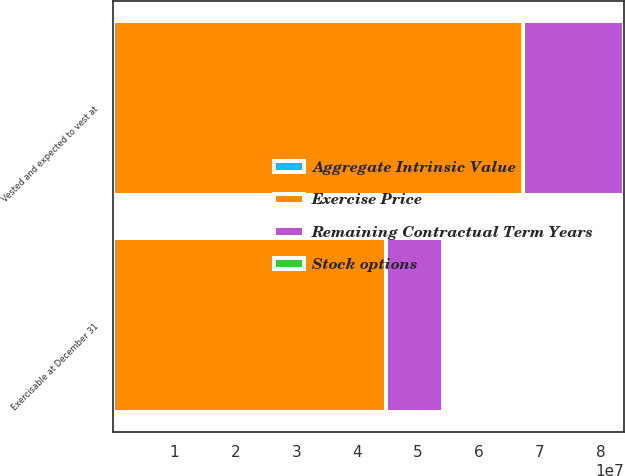<chart> <loc_0><loc_0><loc_500><loc_500><stacked_bar_chart><ecel><fcel>Vested and expected to vest at<fcel>Exercisable at December 31<nl><fcel>Remaining Contractual Term Years<fcel>1.66459e+07<fcel>9.47072e+06<nl><fcel>Aggregate Intrinsic Value<fcel>32.13<fcel>30.87<nl><fcel>Stock options<fcel>6.38<fcel>4.85<nl><fcel>Exercise Price<fcel>6.72353e+07<fcel>4.46579e+07<nl></chart> 